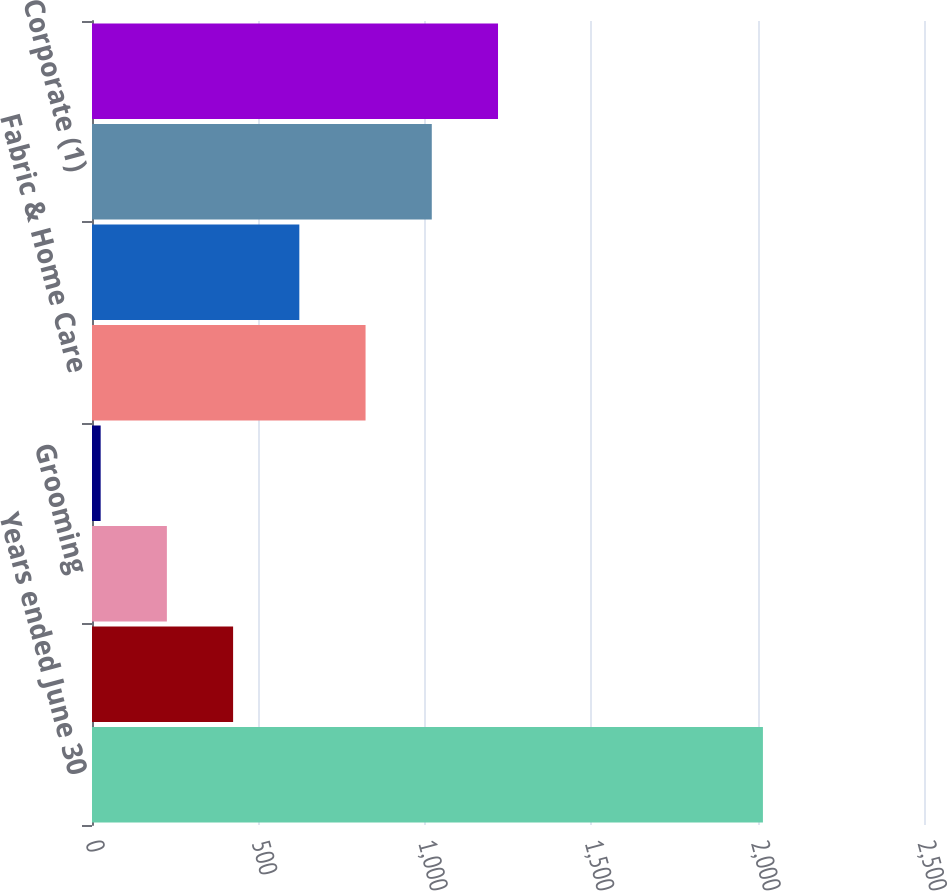Convert chart. <chart><loc_0><loc_0><loc_500><loc_500><bar_chart><fcel>Years ended June 30<fcel>Beauty<fcel>Grooming<fcel>Health Care<fcel>Fabric & Home Care<fcel>Baby Feminine & Family Care<fcel>Corporate (1)<fcel>Total Company<nl><fcel>2016<fcel>424<fcel>225<fcel>26<fcel>822<fcel>623<fcel>1021<fcel>1220<nl></chart> 